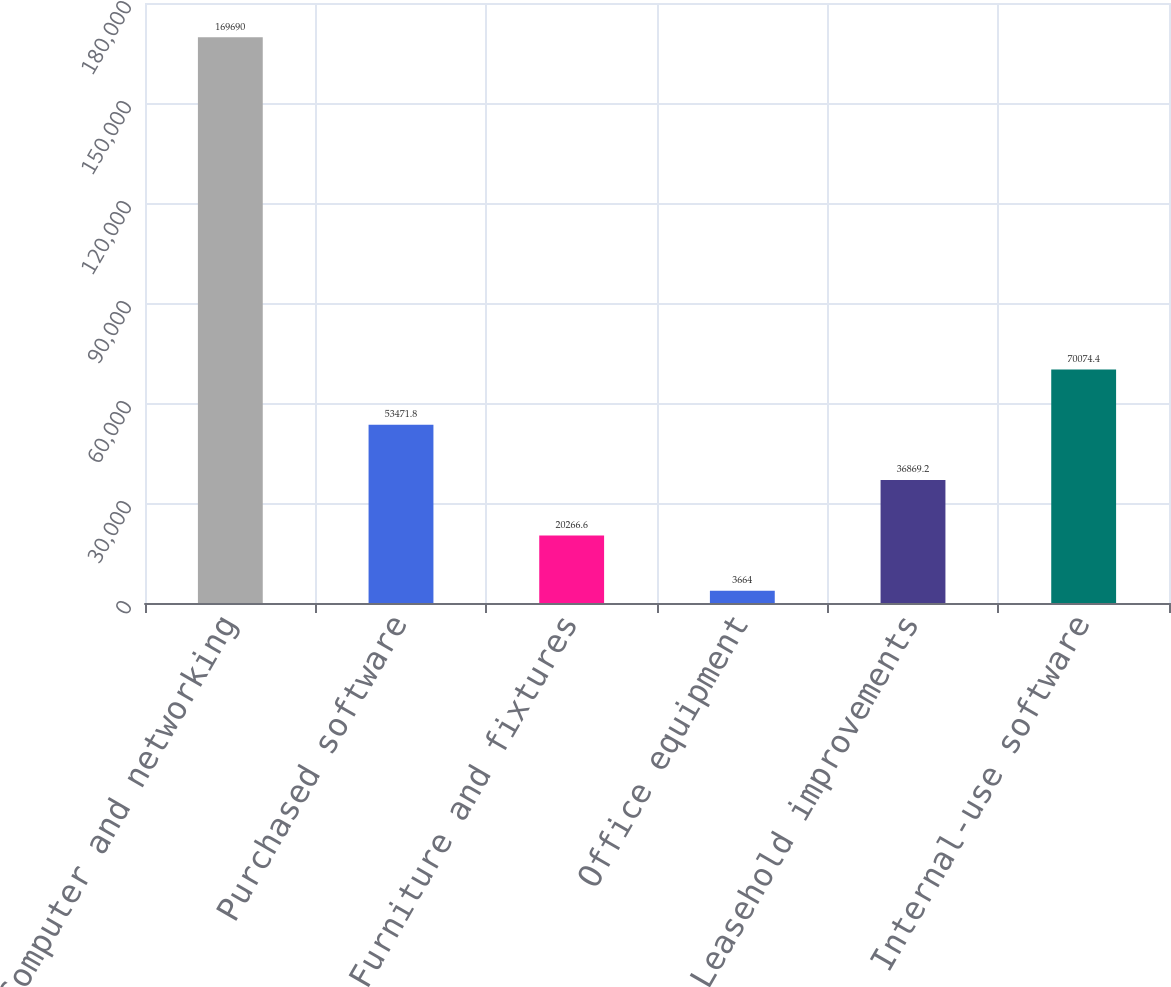Convert chart. <chart><loc_0><loc_0><loc_500><loc_500><bar_chart><fcel>Computer and networking<fcel>Purchased software<fcel>Furniture and fixtures<fcel>Office equipment<fcel>Leasehold improvements<fcel>Internal-use software<nl><fcel>169690<fcel>53471.8<fcel>20266.6<fcel>3664<fcel>36869.2<fcel>70074.4<nl></chart> 